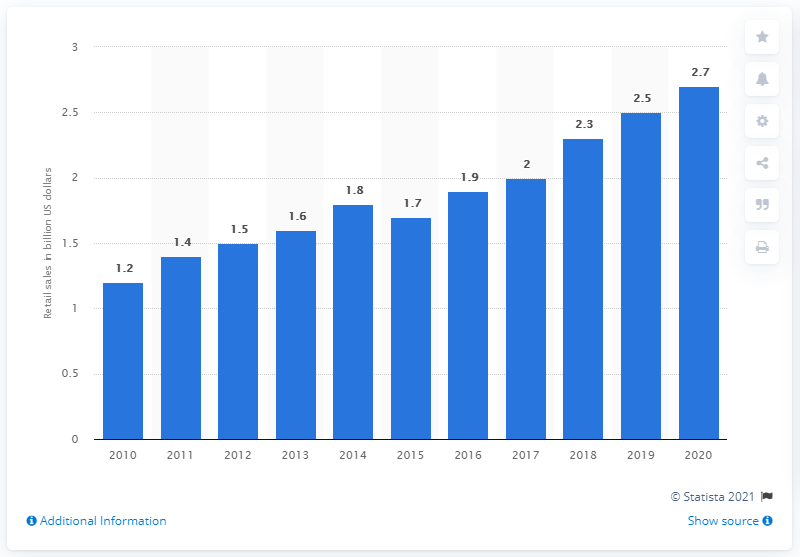Highlight a few significant elements in this photo. In 2010, the retail sales of sports nutrition totaled 1.2 billion U.S. dollars. The retail sales of sports nutrition in 2010 were approximately 2.7 billion dollars. By 2020, the retail sales of sports nutrition are projected to double, increasing from 1.2 billion US dollars in 2010 to 2.7 billion US dollars. 